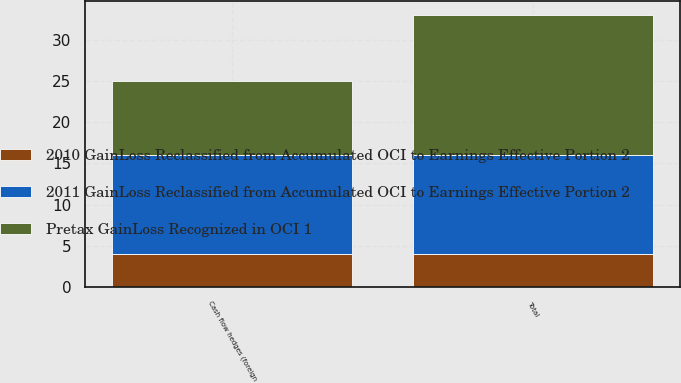Convert chart to OTSL. <chart><loc_0><loc_0><loc_500><loc_500><stacked_bar_chart><ecel><fcel>Cash flow hedges (foreign<fcel>Total<nl><fcel>Pretax GainLoss Recognized in OCI 1<fcel>9<fcel>17<nl><fcel>2011 GainLoss Reclassified from Accumulated OCI to Earnings Effective Portion 2<fcel>12<fcel>12<nl><fcel>2010 GainLoss Reclassified from Accumulated OCI to Earnings Effective Portion 2<fcel>4<fcel>4<nl></chart> 